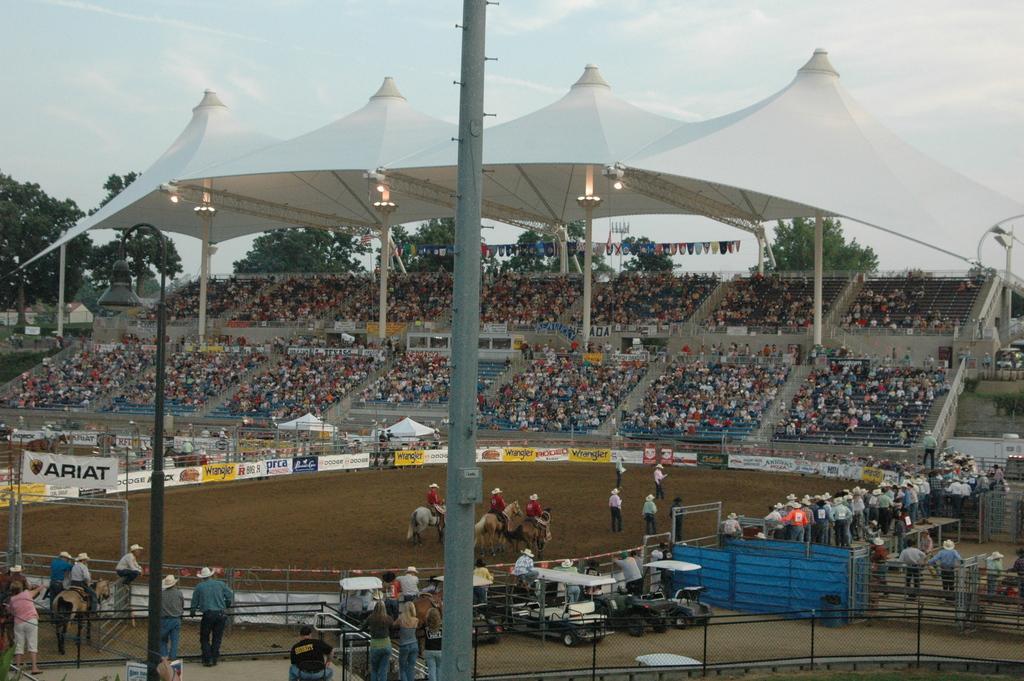How would you summarize this image in a sentence or two? We can see poles, light, vehicles, fences, people, horses and banner. We can see hoardings, stadium, tents, lights, flags and these are audience. In the background we can see trees, house and sky. 